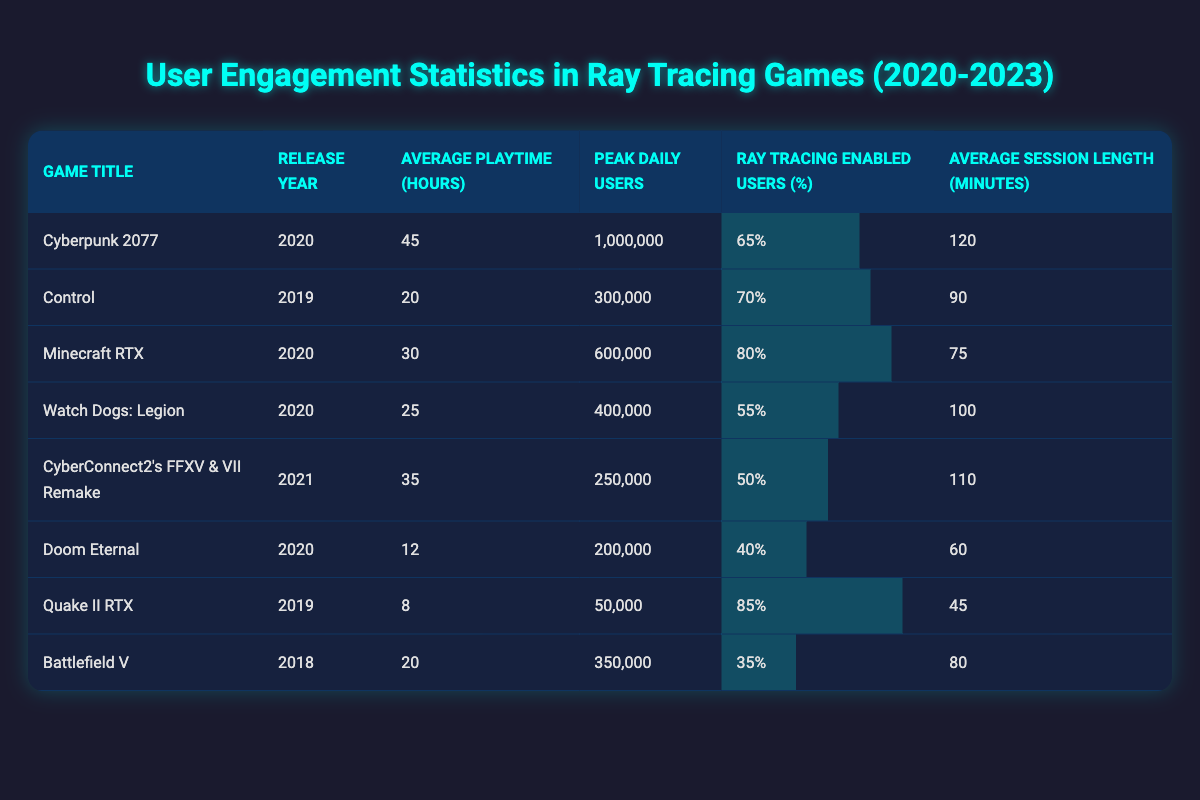What is the peak daily user count for Minecraft RTX? The table lists Minecraft RTX’s peak daily users in the corresponding column, which shows 600,000 users.
Answer: 600,000 Which game has the highest average playtime hours? In the average playtime column, Cyberpunk 2077 has the highest value at 45 hours.
Answer: 45 What is the average session length for Doom Eternal? According to the table, the average session length for Doom Eternal is 60 minutes.
Answer: 60 What percentage of users enabled ray tracing in Control? The ray tracing enabled users percentage for Control is listed as 70%.
Answer: 70% Which game released in 2020 had the lowest peak daily users? By examining the peak daily users column for 2020 releases, Doom Eternal has 200,000, which is less than the others released that year.
Answer: Doom Eternal What is the average peak daily user count for games released in 2020? To find this average, sum the peak daily users for all 2020 games (1,000,000 + 600,000 + 400,000 + 200,000) = 2,300,000. Dividing by the number of games (4) gives an average of 575,000 users.
Answer: 575,000 Is the ray tracing enabled users percentage in Watch Dogs: Legion greater than that in CyberConnect2’s FFXV & VII Remake? Watch Dogs: Legion has 55% and CyberConnect2's game has 50%, therefore the statement is true as 55% is greater than 50%.
Answer: Yes Which game has the longest average session length? Comparing the average session lengths, Cyberpunk 2077 has the longest at 120 minutes, which is more than any other games listed.
Answer: 120 What is the total average playtime (in hours) of all the listed games? To find this, we add the average playtimes: 45 + 20 + 30 + 25 + 35 + 12 + 8 + 20 = 195 hours. This total is then divided by 8 (the number of games listed) giving an average of 24.375 hours.
Answer: 24.375 